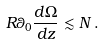Convert formula to latex. <formula><loc_0><loc_0><loc_500><loc_500>R \theta _ { 0 } \frac { d \Omega } { d z } \lesssim N \, .</formula> 